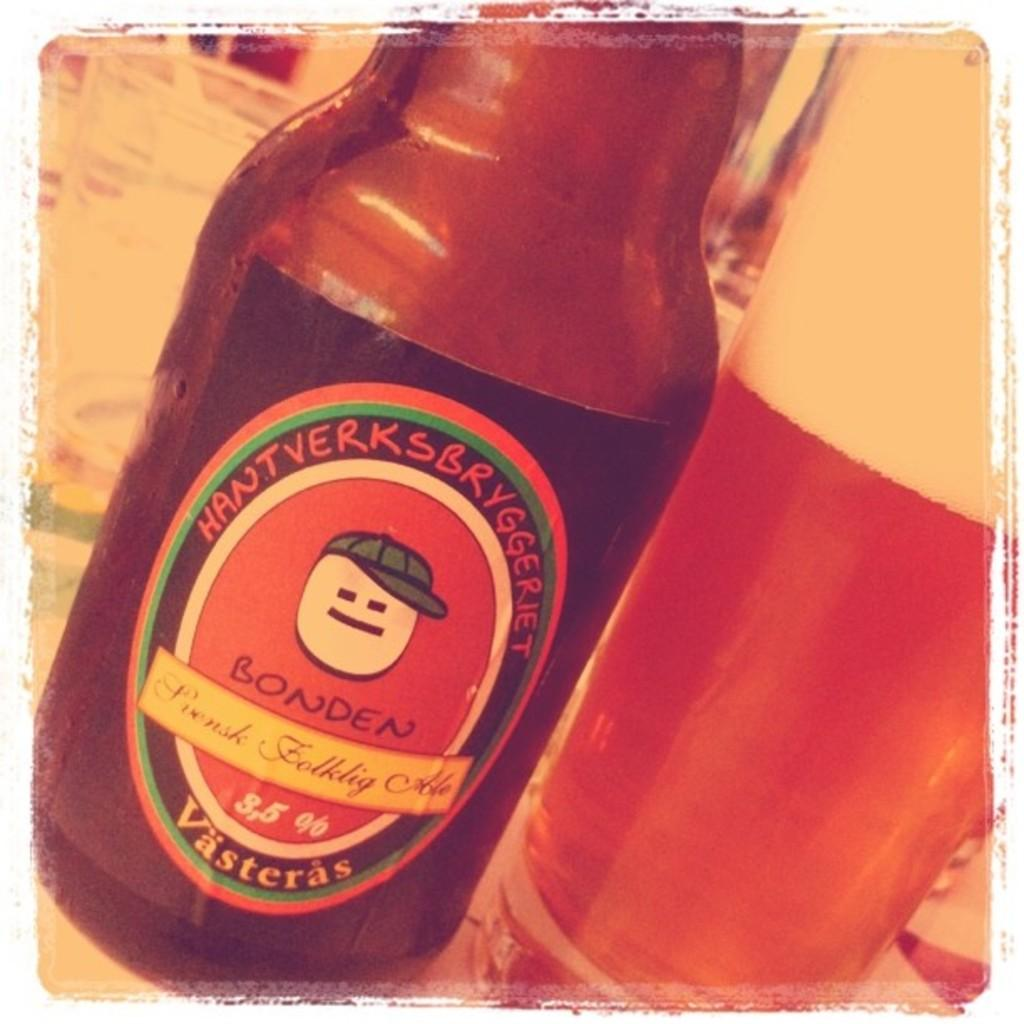<image>
Relay a brief, clear account of the picture shown. A bottle of Bonden Svensk Folklig Ale from Vasteras 